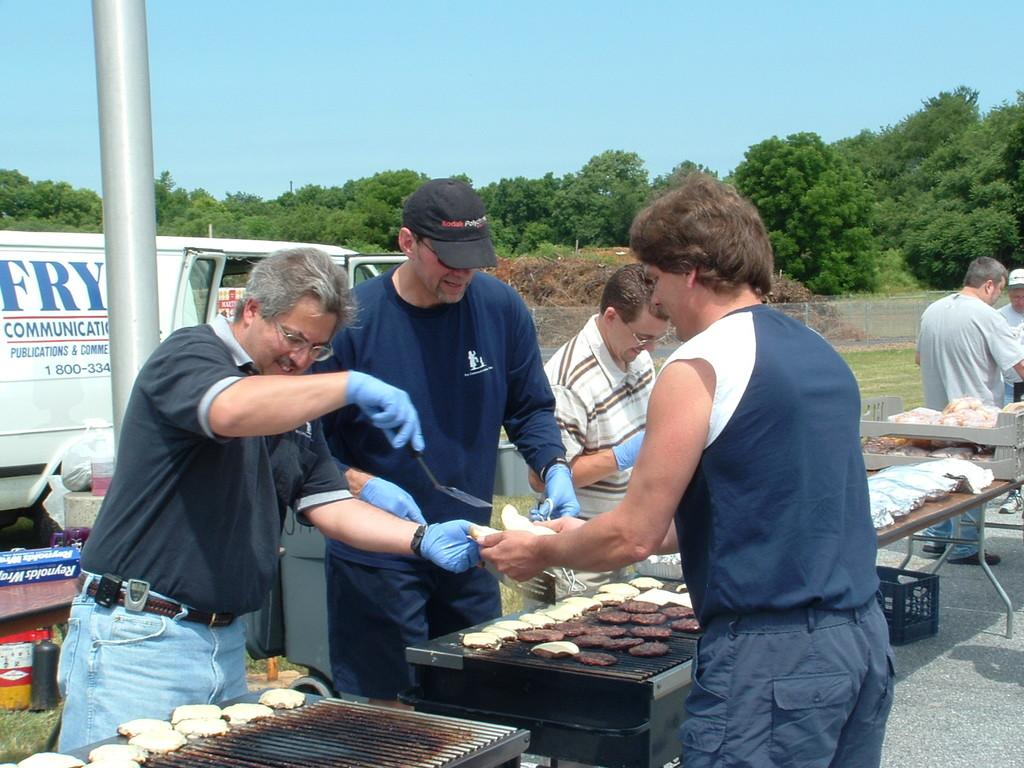Provide a one-sentence caption for the provided image. men grilling hamburgers infront of a fry communications white van. 